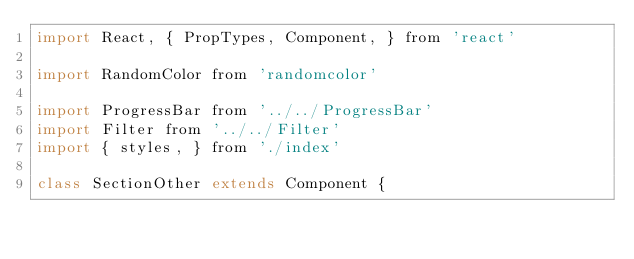Convert code to text. <code><loc_0><loc_0><loc_500><loc_500><_JavaScript_>import React, { PropTypes, Component, } from 'react'

import RandomColor from 'randomcolor'

import ProgressBar from '../../ProgressBar'
import Filter from '../../Filter'
import { styles, } from './index'

class SectionOther extends Component {</code> 